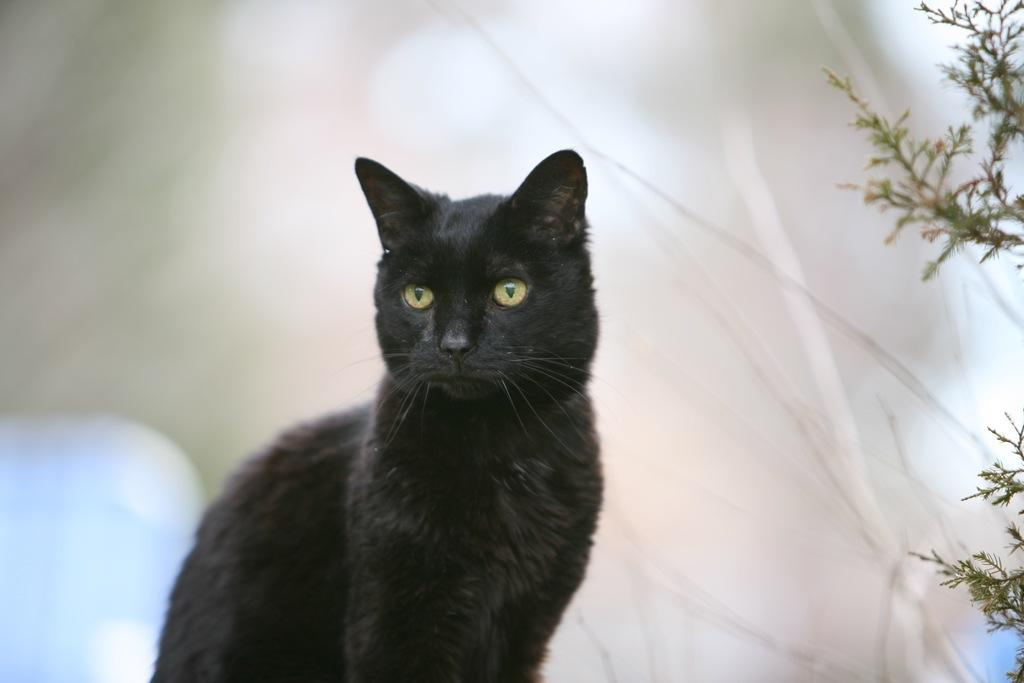What type of animal is in the image? There is a black cat in the image. What other object can be seen in the image? There is a plant on the side in the image. Where is the goldfish swimming in the image? There is no goldfish present in the image. 